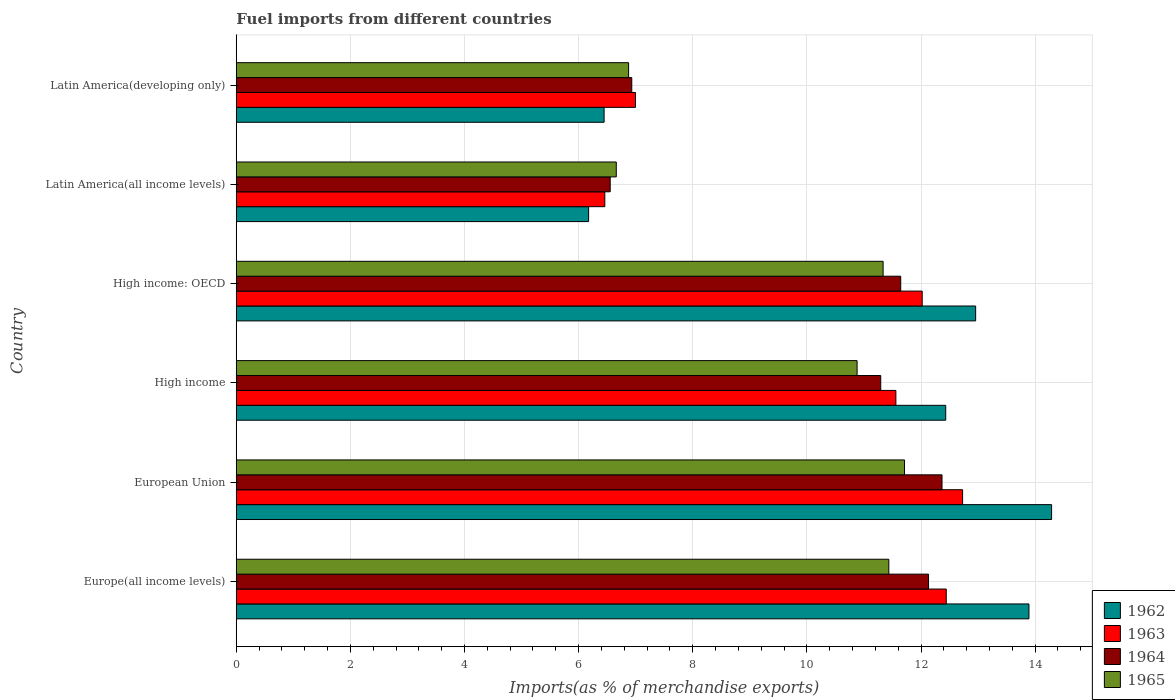How many different coloured bars are there?
Provide a short and direct response. 4. Are the number of bars per tick equal to the number of legend labels?
Your answer should be very brief. Yes. How many bars are there on the 6th tick from the bottom?
Ensure brevity in your answer.  4. What is the label of the 4th group of bars from the top?
Give a very brief answer. High income. What is the percentage of imports to different countries in 1962 in Europe(all income levels)?
Offer a terse response. 13.89. Across all countries, what is the maximum percentage of imports to different countries in 1962?
Provide a short and direct response. 14.29. Across all countries, what is the minimum percentage of imports to different countries in 1964?
Keep it short and to the point. 6.55. In which country was the percentage of imports to different countries in 1963 minimum?
Your response must be concise. Latin America(all income levels). What is the total percentage of imports to different countries in 1964 in the graph?
Ensure brevity in your answer.  60.92. What is the difference between the percentage of imports to different countries in 1964 in Europe(all income levels) and that in Latin America(developing only)?
Your answer should be compact. 5.2. What is the difference between the percentage of imports to different countries in 1965 in Latin America(all income levels) and the percentage of imports to different countries in 1963 in High income?
Give a very brief answer. -4.9. What is the average percentage of imports to different countries in 1965 per country?
Keep it short and to the point. 9.82. What is the difference between the percentage of imports to different countries in 1964 and percentage of imports to different countries in 1962 in European Union?
Offer a very short reply. -1.92. What is the ratio of the percentage of imports to different countries in 1963 in High income: OECD to that in Latin America(developing only)?
Your answer should be compact. 1.72. Is the percentage of imports to different countries in 1963 in High income: OECD less than that in Latin America(developing only)?
Provide a short and direct response. No. Is the difference between the percentage of imports to different countries in 1964 in High income: OECD and Latin America(all income levels) greater than the difference between the percentage of imports to different countries in 1962 in High income: OECD and Latin America(all income levels)?
Give a very brief answer. No. What is the difference between the highest and the second highest percentage of imports to different countries in 1965?
Give a very brief answer. 0.27. What is the difference between the highest and the lowest percentage of imports to different countries in 1964?
Make the answer very short. 5.81. In how many countries, is the percentage of imports to different countries in 1965 greater than the average percentage of imports to different countries in 1965 taken over all countries?
Your answer should be very brief. 4. Is the sum of the percentage of imports to different countries in 1965 in Europe(all income levels) and European Union greater than the maximum percentage of imports to different countries in 1962 across all countries?
Give a very brief answer. Yes. Is it the case that in every country, the sum of the percentage of imports to different countries in 1963 and percentage of imports to different countries in 1962 is greater than the sum of percentage of imports to different countries in 1964 and percentage of imports to different countries in 1965?
Your answer should be compact. No. What does the 4th bar from the bottom in Latin America(developing only) represents?
Provide a short and direct response. 1965. Is it the case that in every country, the sum of the percentage of imports to different countries in 1962 and percentage of imports to different countries in 1964 is greater than the percentage of imports to different countries in 1965?
Your answer should be very brief. Yes. How many bars are there?
Give a very brief answer. 24. Are all the bars in the graph horizontal?
Provide a short and direct response. Yes. What is the difference between two consecutive major ticks on the X-axis?
Your answer should be very brief. 2. Does the graph contain any zero values?
Offer a terse response. No. How many legend labels are there?
Your answer should be compact. 4. What is the title of the graph?
Ensure brevity in your answer.  Fuel imports from different countries. Does "1975" appear as one of the legend labels in the graph?
Your response must be concise. No. What is the label or title of the X-axis?
Offer a terse response. Imports(as % of merchandise exports). What is the label or title of the Y-axis?
Keep it short and to the point. Country. What is the Imports(as % of merchandise exports) in 1962 in Europe(all income levels)?
Your response must be concise. 13.89. What is the Imports(as % of merchandise exports) of 1963 in Europe(all income levels)?
Keep it short and to the point. 12.44. What is the Imports(as % of merchandise exports) in 1964 in Europe(all income levels)?
Make the answer very short. 12.13. What is the Imports(as % of merchandise exports) of 1965 in Europe(all income levels)?
Give a very brief answer. 11.44. What is the Imports(as % of merchandise exports) of 1962 in European Union?
Keep it short and to the point. 14.29. What is the Imports(as % of merchandise exports) in 1963 in European Union?
Give a very brief answer. 12.73. What is the Imports(as % of merchandise exports) of 1964 in European Union?
Offer a very short reply. 12.37. What is the Imports(as % of merchandise exports) in 1965 in European Union?
Offer a very short reply. 11.71. What is the Imports(as % of merchandise exports) in 1962 in High income?
Provide a short and direct response. 12.43. What is the Imports(as % of merchandise exports) of 1963 in High income?
Offer a very short reply. 11.56. What is the Imports(as % of merchandise exports) of 1964 in High income?
Offer a very short reply. 11.29. What is the Imports(as % of merchandise exports) in 1965 in High income?
Your response must be concise. 10.88. What is the Imports(as % of merchandise exports) in 1962 in High income: OECD?
Your answer should be compact. 12.96. What is the Imports(as % of merchandise exports) of 1963 in High income: OECD?
Provide a short and direct response. 12.02. What is the Imports(as % of merchandise exports) of 1964 in High income: OECD?
Provide a short and direct response. 11.64. What is the Imports(as % of merchandise exports) of 1965 in High income: OECD?
Provide a short and direct response. 11.34. What is the Imports(as % of merchandise exports) of 1962 in Latin America(all income levels)?
Keep it short and to the point. 6.17. What is the Imports(as % of merchandise exports) of 1963 in Latin America(all income levels)?
Your answer should be compact. 6.46. What is the Imports(as % of merchandise exports) of 1964 in Latin America(all income levels)?
Make the answer very short. 6.55. What is the Imports(as % of merchandise exports) in 1965 in Latin America(all income levels)?
Offer a terse response. 6.66. What is the Imports(as % of merchandise exports) of 1962 in Latin America(developing only)?
Give a very brief answer. 6.45. What is the Imports(as % of merchandise exports) in 1963 in Latin America(developing only)?
Give a very brief answer. 7. What is the Imports(as % of merchandise exports) in 1964 in Latin America(developing only)?
Provide a succinct answer. 6.93. What is the Imports(as % of merchandise exports) in 1965 in Latin America(developing only)?
Give a very brief answer. 6.88. Across all countries, what is the maximum Imports(as % of merchandise exports) of 1962?
Keep it short and to the point. 14.29. Across all countries, what is the maximum Imports(as % of merchandise exports) in 1963?
Keep it short and to the point. 12.73. Across all countries, what is the maximum Imports(as % of merchandise exports) of 1964?
Ensure brevity in your answer.  12.37. Across all countries, what is the maximum Imports(as % of merchandise exports) in 1965?
Your answer should be compact. 11.71. Across all countries, what is the minimum Imports(as % of merchandise exports) of 1962?
Provide a short and direct response. 6.17. Across all countries, what is the minimum Imports(as % of merchandise exports) of 1963?
Give a very brief answer. 6.46. Across all countries, what is the minimum Imports(as % of merchandise exports) of 1964?
Your response must be concise. 6.55. Across all countries, what is the minimum Imports(as % of merchandise exports) of 1965?
Offer a terse response. 6.66. What is the total Imports(as % of merchandise exports) in 1962 in the graph?
Provide a succinct answer. 66.19. What is the total Imports(as % of merchandise exports) of 1963 in the graph?
Make the answer very short. 62.21. What is the total Imports(as % of merchandise exports) in 1964 in the graph?
Provide a succinct answer. 60.92. What is the total Imports(as % of merchandise exports) in 1965 in the graph?
Provide a short and direct response. 58.9. What is the difference between the Imports(as % of merchandise exports) of 1962 in Europe(all income levels) and that in European Union?
Provide a short and direct response. -0.4. What is the difference between the Imports(as % of merchandise exports) of 1963 in Europe(all income levels) and that in European Union?
Your answer should be very brief. -0.29. What is the difference between the Imports(as % of merchandise exports) in 1964 in Europe(all income levels) and that in European Union?
Keep it short and to the point. -0.24. What is the difference between the Imports(as % of merchandise exports) of 1965 in Europe(all income levels) and that in European Union?
Offer a terse response. -0.27. What is the difference between the Imports(as % of merchandise exports) in 1962 in Europe(all income levels) and that in High income?
Your answer should be compact. 1.46. What is the difference between the Imports(as % of merchandise exports) in 1963 in Europe(all income levels) and that in High income?
Provide a succinct answer. 0.88. What is the difference between the Imports(as % of merchandise exports) in 1964 in Europe(all income levels) and that in High income?
Provide a short and direct response. 0.84. What is the difference between the Imports(as % of merchandise exports) of 1965 in Europe(all income levels) and that in High income?
Keep it short and to the point. 0.56. What is the difference between the Imports(as % of merchandise exports) of 1962 in Europe(all income levels) and that in High income: OECD?
Give a very brief answer. 0.93. What is the difference between the Imports(as % of merchandise exports) of 1963 in Europe(all income levels) and that in High income: OECD?
Ensure brevity in your answer.  0.42. What is the difference between the Imports(as % of merchandise exports) in 1964 in Europe(all income levels) and that in High income: OECD?
Your response must be concise. 0.49. What is the difference between the Imports(as % of merchandise exports) of 1965 in Europe(all income levels) and that in High income: OECD?
Provide a succinct answer. 0.1. What is the difference between the Imports(as % of merchandise exports) in 1962 in Europe(all income levels) and that in Latin America(all income levels)?
Give a very brief answer. 7.72. What is the difference between the Imports(as % of merchandise exports) of 1963 in Europe(all income levels) and that in Latin America(all income levels)?
Your answer should be very brief. 5.98. What is the difference between the Imports(as % of merchandise exports) in 1964 in Europe(all income levels) and that in Latin America(all income levels)?
Keep it short and to the point. 5.58. What is the difference between the Imports(as % of merchandise exports) of 1965 in Europe(all income levels) and that in Latin America(all income levels)?
Provide a short and direct response. 4.78. What is the difference between the Imports(as % of merchandise exports) of 1962 in Europe(all income levels) and that in Latin America(developing only)?
Offer a very short reply. 7.45. What is the difference between the Imports(as % of merchandise exports) of 1963 in Europe(all income levels) and that in Latin America(developing only)?
Provide a short and direct response. 5.45. What is the difference between the Imports(as % of merchandise exports) in 1964 in Europe(all income levels) and that in Latin America(developing only)?
Your response must be concise. 5.2. What is the difference between the Imports(as % of merchandise exports) in 1965 in Europe(all income levels) and that in Latin America(developing only)?
Offer a very short reply. 4.56. What is the difference between the Imports(as % of merchandise exports) in 1962 in European Union and that in High income?
Offer a terse response. 1.86. What is the difference between the Imports(as % of merchandise exports) of 1963 in European Union and that in High income?
Offer a terse response. 1.17. What is the difference between the Imports(as % of merchandise exports) of 1964 in European Union and that in High income?
Keep it short and to the point. 1.07. What is the difference between the Imports(as % of merchandise exports) of 1965 in European Union and that in High income?
Make the answer very short. 0.83. What is the difference between the Imports(as % of merchandise exports) of 1962 in European Union and that in High income: OECD?
Give a very brief answer. 1.33. What is the difference between the Imports(as % of merchandise exports) in 1963 in European Union and that in High income: OECD?
Offer a very short reply. 0.71. What is the difference between the Imports(as % of merchandise exports) in 1964 in European Union and that in High income: OECD?
Your answer should be very brief. 0.72. What is the difference between the Imports(as % of merchandise exports) of 1965 in European Union and that in High income: OECD?
Give a very brief answer. 0.38. What is the difference between the Imports(as % of merchandise exports) of 1962 in European Union and that in Latin America(all income levels)?
Keep it short and to the point. 8.11. What is the difference between the Imports(as % of merchandise exports) of 1963 in European Union and that in Latin America(all income levels)?
Keep it short and to the point. 6.27. What is the difference between the Imports(as % of merchandise exports) in 1964 in European Union and that in Latin America(all income levels)?
Keep it short and to the point. 5.82. What is the difference between the Imports(as % of merchandise exports) in 1965 in European Union and that in Latin America(all income levels)?
Your response must be concise. 5.05. What is the difference between the Imports(as % of merchandise exports) of 1962 in European Union and that in Latin America(developing only)?
Give a very brief answer. 7.84. What is the difference between the Imports(as % of merchandise exports) in 1963 in European Union and that in Latin America(developing only)?
Offer a very short reply. 5.73. What is the difference between the Imports(as % of merchandise exports) of 1964 in European Union and that in Latin America(developing only)?
Make the answer very short. 5.44. What is the difference between the Imports(as % of merchandise exports) in 1965 in European Union and that in Latin America(developing only)?
Provide a succinct answer. 4.84. What is the difference between the Imports(as % of merchandise exports) in 1962 in High income and that in High income: OECD?
Your response must be concise. -0.52. What is the difference between the Imports(as % of merchandise exports) of 1963 in High income and that in High income: OECD?
Ensure brevity in your answer.  -0.46. What is the difference between the Imports(as % of merchandise exports) of 1964 in High income and that in High income: OECD?
Make the answer very short. -0.35. What is the difference between the Imports(as % of merchandise exports) in 1965 in High income and that in High income: OECD?
Your response must be concise. -0.46. What is the difference between the Imports(as % of merchandise exports) of 1962 in High income and that in Latin America(all income levels)?
Provide a short and direct response. 6.26. What is the difference between the Imports(as % of merchandise exports) of 1963 in High income and that in Latin America(all income levels)?
Your answer should be very brief. 5.1. What is the difference between the Imports(as % of merchandise exports) of 1964 in High income and that in Latin America(all income levels)?
Your answer should be very brief. 4.74. What is the difference between the Imports(as % of merchandise exports) in 1965 in High income and that in Latin America(all income levels)?
Offer a very short reply. 4.22. What is the difference between the Imports(as % of merchandise exports) in 1962 in High income and that in Latin America(developing only)?
Your answer should be compact. 5.99. What is the difference between the Imports(as % of merchandise exports) in 1963 in High income and that in Latin America(developing only)?
Your response must be concise. 4.56. What is the difference between the Imports(as % of merchandise exports) of 1964 in High income and that in Latin America(developing only)?
Offer a terse response. 4.36. What is the difference between the Imports(as % of merchandise exports) of 1965 in High income and that in Latin America(developing only)?
Keep it short and to the point. 4. What is the difference between the Imports(as % of merchandise exports) of 1962 in High income: OECD and that in Latin America(all income levels)?
Ensure brevity in your answer.  6.78. What is the difference between the Imports(as % of merchandise exports) of 1963 in High income: OECD and that in Latin America(all income levels)?
Keep it short and to the point. 5.56. What is the difference between the Imports(as % of merchandise exports) of 1964 in High income: OECD and that in Latin America(all income levels)?
Offer a terse response. 5.09. What is the difference between the Imports(as % of merchandise exports) in 1965 in High income: OECD and that in Latin America(all income levels)?
Keep it short and to the point. 4.68. What is the difference between the Imports(as % of merchandise exports) of 1962 in High income: OECD and that in Latin America(developing only)?
Make the answer very short. 6.51. What is the difference between the Imports(as % of merchandise exports) in 1963 in High income: OECD and that in Latin America(developing only)?
Offer a terse response. 5.02. What is the difference between the Imports(as % of merchandise exports) of 1964 in High income: OECD and that in Latin America(developing only)?
Your answer should be compact. 4.71. What is the difference between the Imports(as % of merchandise exports) of 1965 in High income: OECD and that in Latin America(developing only)?
Your answer should be very brief. 4.46. What is the difference between the Imports(as % of merchandise exports) in 1962 in Latin America(all income levels) and that in Latin America(developing only)?
Your answer should be very brief. -0.27. What is the difference between the Imports(as % of merchandise exports) of 1963 in Latin America(all income levels) and that in Latin America(developing only)?
Your response must be concise. -0.54. What is the difference between the Imports(as % of merchandise exports) of 1964 in Latin America(all income levels) and that in Latin America(developing only)?
Make the answer very short. -0.38. What is the difference between the Imports(as % of merchandise exports) in 1965 in Latin America(all income levels) and that in Latin America(developing only)?
Your answer should be very brief. -0.22. What is the difference between the Imports(as % of merchandise exports) in 1962 in Europe(all income levels) and the Imports(as % of merchandise exports) in 1963 in European Union?
Your answer should be very brief. 1.16. What is the difference between the Imports(as % of merchandise exports) of 1962 in Europe(all income levels) and the Imports(as % of merchandise exports) of 1964 in European Union?
Offer a very short reply. 1.52. What is the difference between the Imports(as % of merchandise exports) in 1962 in Europe(all income levels) and the Imports(as % of merchandise exports) in 1965 in European Union?
Give a very brief answer. 2.18. What is the difference between the Imports(as % of merchandise exports) in 1963 in Europe(all income levels) and the Imports(as % of merchandise exports) in 1964 in European Union?
Give a very brief answer. 0.07. What is the difference between the Imports(as % of merchandise exports) of 1963 in Europe(all income levels) and the Imports(as % of merchandise exports) of 1965 in European Union?
Your response must be concise. 0.73. What is the difference between the Imports(as % of merchandise exports) in 1964 in Europe(all income levels) and the Imports(as % of merchandise exports) in 1965 in European Union?
Offer a terse response. 0.42. What is the difference between the Imports(as % of merchandise exports) in 1962 in Europe(all income levels) and the Imports(as % of merchandise exports) in 1963 in High income?
Ensure brevity in your answer.  2.33. What is the difference between the Imports(as % of merchandise exports) in 1962 in Europe(all income levels) and the Imports(as % of merchandise exports) in 1964 in High income?
Make the answer very short. 2.6. What is the difference between the Imports(as % of merchandise exports) of 1962 in Europe(all income levels) and the Imports(as % of merchandise exports) of 1965 in High income?
Keep it short and to the point. 3.01. What is the difference between the Imports(as % of merchandise exports) of 1963 in Europe(all income levels) and the Imports(as % of merchandise exports) of 1964 in High income?
Offer a terse response. 1.15. What is the difference between the Imports(as % of merchandise exports) in 1963 in Europe(all income levels) and the Imports(as % of merchandise exports) in 1965 in High income?
Your answer should be very brief. 1.56. What is the difference between the Imports(as % of merchandise exports) of 1964 in Europe(all income levels) and the Imports(as % of merchandise exports) of 1965 in High income?
Offer a very short reply. 1.25. What is the difference between the Imports(as % of merchandise exports) in 1962 in Europe(all income levels) and the Imports(as % of merchandise exports) in 1963 in High income: OECD?
Give a very brief answer. 1.87. What is the difference between the Imports(as % of merchandise exports) in 1962 in Europe(all income levels) and the Imports(as % of merchandise exports) in 1964 in High income: OECD?
Your answer should be very brief. 2.25. What is the difference between the Imports(as % of merchandise exports) of 1962 in Europe(all income levels) and the Imports(as % of merchandise exports) of 1965 in High income: OECD?
Provide a short and direct response. 2.56. What is the difference between the Imports(as % of merchandise exports) in 1963 in Europe(all income levels) and the Imports(as % of merchandise exports) in 1964 in High income: OECD?
Your answer should be compact. 0.8. What is the difference between the Imports(as % of merchandise exports) in 1963 in Europe(all income levels) and the Imports(as % of merchandise exports) in 1965 in High income: OECD?
Make the answer very short. 1.11. What is the difference between the Imports(as % of merchandise exports) of 1964 in Europe(all income levels) and the Imports(as % of merchandise exports) of 1965 in High income: OECD?
Make the answer very short. 0.8. What is the difference between the Imports(as % of merchandise exports) in 1962 in Europe(all income levels) and the Imports(as % of merchandise exports) in 1963 in Latin America(all income levels)?
Offer a very short reply. 7.43. What is the difference between the Imports(as % of merchandise exports) in 1962 in Europe(all income levels) and the Imports(as % of merchandise exports) in 1964 in Latin America(all income levels)?
Offer a terse response. 7.34. What is the difference between the Imports(as % of merchandise exports) of 1962 in Europe(all income levels) and the Imports(as % of merchandise exports) of 1965 in Latin America(all income levels)?
Offer a very short reply. 7.23. What is the difference between the Imports(as % of merchandise exports) in 1963 in Europe(all income levels) and the Imports(as % of merchandise exports) in 1964 in Latin America(all income levels)?
Provide a short and direct response. 5.89. What is the difference between the Imports(as % of merchandise exports) in 1963 in Europe(all income levels) and the Imports(as % of merchandise exports) in 1965 in Latin America(all income levels)?
Offer a very short reply. 5.78. What is the difference between the Imports(as % of merchandise exports) of 1964 in Europe(all income levels) and the Imports(as % of merchandise exports) of 1965 in Latin America(all income levels)?
Your answer should be very brief. 5.47. What is the difference between the Imports(as % of merchandise exports) in 1962 in Europe(all income levels) and the Imports(as % of merchandise exports) in 1963 in Latin America(developing only)?
Ensure brevity in your answer.  6.9. What is the difference between the Imports(as % of merchandise exports) in 1962 in Europe(all income levels) and the Imports(as % of merchandise exports) in 1964 in Latin America(developing only)?
Your answer should be very brief. 6.96. What is the difference between the Imports(as % of merchandise exports) in 1962 in Europe(all income levels) and the Imports(as % of merchandise exports) in 1965 in Latin America(developing only)?
Your answer should be compact. 7.02. What is the difference between the Imports(as % of merchandise exports) in 1963 in Europe(all income levels) and the Imports(as % of merchandise exports) in 1964 in Latin America(developing only)?
Provide a short and direct response. 5.51. What is the difference between the Imports(as % of merchandise exports) in 1963 in Europe(all income levels) and the Imports(as % of merchandise exports) in 1965 in Latin America(developing only)?
Your answer should be compact. 5.57. What is the difference between the Imports(as % of merchandise exports) of 1964 in Europe(all income levels) and the Imports(as % of merchandise exports) of 1965 in Latin America(developing only)?
Give a very brief answer. 5.26. What is the difference between the Imports(as % of merchandise exports) in 1962 in European Union and the Imports(as % of merchandise exports) in 1963 in High income?
Offer a terse response. 2.73. What is the difference between the Imports(as % of merchandise exports) of 1962 in European Union and the Imports(as % of merchandise exports) of 1964 in High income?
Offer a very short reply. 2.99. What is the difference between the Imports(as % of merchandise exports) in 1962 in European Union and the Imports(as % of merchandise exports) in 1965 in High income?
Provide a succinct answer. 3.41. What is the difference between the Imports(as % of merchandise exports) of 1963 in European Union and the Imports(as % of merchandise exports) of 1964 in High income?
Your answer should be very brief. 1.43. What is the difference between the Imports(as % of merchandise exports) of 1963 in European Union and the Imports(as % of merchandise exports) of 1965 in High income?
Your answer should be compact. 1.85. What is the difference between the Imports(as % of merchandise exports) in 1964 in European Union and the Imports(as % of merchandise exports) in 1965 in High income?
Provide a short and direct response. 1.49. What is the difference between the Imports(as % of merchandise exports) in 1962 in European Union and the Imports(as % of merchandise exports) in 1963 in High income: OECD?
Ensure brevity in your answer.  2.27. What is the difference between the Imports(as % of merchandise exports) in 1962 in European Union and the Imports(as % of merchandise exports) in 1964 in High income: OECD?
Your response must be concise. 2.64. What is the difference between the Imports(as % of merchandise exports) in 1962 in European Union and the Imports(as % of merchandise exports) in 1965 in High income: OECD?
Offer a terse response. 2.95. What is the difference between the Imports(as % of merchandise exports) in 1963 in European Union and the Imports(as % of merchandise exports) in 1964 in High income: OECD?
Your response must be concise. 1.08. What is the difference between the Imports(as % of merchandise exports) in 1963 in European Union and the Imports(as % of merchandise exports) in 1965 in High income: OECD?
Give a very brief answer. 1.39. What is the difference between the Imports(as % of merchandise exports) in 1964 in European Union and the Imports(as % of merchandise exports) in 1965 in High income: OECD?
Offer a terse response. 1.03. What is the difference between the Imports(as % of merchandise exports) in 1962 in European Union and the Imports(as % of merchandise exports) in 1963 in Latin America(all income levels)?
Provide a succinct answer. 7.83. What is the difference between the Imports(as % of merchandise exports) of 1962 in European Union and the Imports(as % of merchandise exports) of 1964 in Latin America(all income levels)?
Provide a short and direct response. 7.74. What is the difference between the Imports(as % of merchandise exports) in 1962 in European Union and the Imports(as % of merchandise exports) in 1965 in Latin America(all income levels)?
Your response must be concise. 7.63. What is the difference between the Imports(as % of merchandise exports) in 1963 in European Union and the Imports(as % of merchandise exports) in 1964 in Latin America(all income levels)?
Make the answer very short. 6.18. What is the difference between the Imports(as % of merchandise exports) of 1963 in European Union and the Imports(as % of merchandise exports) of 1965 in Latin America(all income levels)?
Your answer should be very brief. 6.07. What is the difference between the Imports(as % of merchandise exports) of 1964 in European Union and the Imports(as % of merchandise exports) of 1965 in Latin America(all income levels)?
Provide a succinct answer. 5.71. What is the difference between the Imports(as % of merchandise exports) in 1962 in European Union and the Imports(as % of merchandise exports) in 1963 in Latin America(developing only)?
Give a very brief answer. 7.29. What is the difference between the Imports(as % of merchandise exports) of 1962 in European Union and the Imports(as % of merchandise exports) of 1964 in Latin America(developing only)?
Your response must be concise. 7.36. What is the difference between the Imports(as % of merchandise exports) of 1962 in European Union and the Imports(as % of merchandise exports) of 1965 in Latin America(developing only)?
Keep it short and to the point. 7.41. What is the difference between the Imports(as % of merchandise exports) of 1963 in European Union and the Imports(as % of merchandise exports) of 1964 in Latin America(developing only)?
Your answer should be very brief. 5.8. What is the difference between the Imports(as % of merchandise exports) of 1963 in European Union and the Imports(as % of merchandise exports) of 1965 in Latin America(developing only)?
Provide a short and direct response. 5.85. What is the difference between the Imports(as % of merchandise exports) of 1964 in European Union and the Imports(as % of merchandise exports) of 1965 in Latin America(developing only)?
Offer a terse response. 5.49. What is the difference between the Imports(as % of merchandise exports) in 1962 in High income and the Imports(as % of merchandise exports) in 1963 in High income: OECD?
Your answer should be very brief. 0.41. What is the difference between the Imports(as % of merchandise exports) of 1962 in High income and the Imports(as % of merchandise exports) of 1964 in High income: OECD?
Keep it short and to the point. 0.79. What is the difference between the Imports(as % of merchandise exports) in 1962 in High income and the Imports(as % of merchandise exports) in 1965 in High income: OECD?
Offer a very short reply. 1.1. What is the difference between the Imports(as % of merchandise exports) in 1963 in High income and the Imports(as % of merchandise exports) in 1964 in High income: OECD?
Ensure brevity in your answer.  -0.09. What is the difference between the Imports(as % of merchandise exports) in 1963 in High income and the Imports(as % of merchandise exports) in 1965 in High income: OECD?
Your answer should be very brief. 0.22. What is the difference between the Imports(as % of merchandise exports) in 1964 in High income and the Imports(as % of merchandise exports) in 1965 in High income: OECD?
Ensure brevity in your answer.  -0.04. What is the difference between the Imports(as % of merchandise exports) in 1962 in High income and the Imports(as % of merchandise exports) in 1963 in Latin America(all income levels)?
Your response must be concise. 5.97. What is the difference between the Imports(as % of merchandise exports) of 1962 in High income and the Imports(as % of merchandise exports) of 1964 in Latin America(all income levels)?
Provide a succinct answer. 5.88. What is the difference between the Imports(as % of merchandise exports) of 1962 in High income and the Imports(as % of merchandise exports) of 1965 in Latin America(all income levels)?
Provide a succinct answer. 5.77. What is the difference between the Imports(as % of merchandise exports) of 1963 in High income and the Imports(as % of merchandise exports) of 1964 in Latin America(all income levels)?
Keep it short and to the point. 5.01. What is the difference between the Imports(as % of merchandise exports) of 1963 in High income and the Imports(as % of merchandise exports) of 1965 in Latin America(all income levels)?
Provide a succinct answer. 4.9. What is the difference between the Imports(as % of merchandise exports) in 1964 in High income and the Imports(as % of merchandise exports) in 1965 in Latin America(all income levels)?
Your response must be concise. 4.63. What is the difference between the Imports(as % of merchandise exports) in 1962 in High income and the Imports(as % of merchandise exports) in 1963 in Latin America(developing only)?
Give a very brief answer. 5.44. What is the difference between the Imports(as % of merchandise exports) in 1962 in High income and the Imports(as % of merchandise exports) in 1964 in Latin America(developing only)?
Offer a terse response. 5.5. What is the difference between the Imports(as % of merchandise exports) in 1962 in High income and the Imports(as % of merchandise exports) in 1965 in Latin America(developing only)?
Keep it short and to the point. 5.56. What is the difference between the Imports(as % of merchandise exports) of 1963 in High income and the Imports(as % of merchandise exports) of 1964 in Latin America(developing only)?
Your answer should be very brief. 4.63. What is the difference between the Imports(as % of merchandise exports) in 1963 in High income and the Imports(as % of merchandise exports) in 1965 in Latin America(developing only)?
Ensure brevity in your answer.  4.68. What is the difference between the Imports(as % of merchandise exports) of 1964 in High income and the Imports(as % of merchandise exports) of 1965 in Latin America(developing only)?
Provide a short and direct response. 4.42. What is the difference between the Imports(as % of merchandise exports) in 1962 in High income: OECD and the Imports(as % of merchandise exports) in 1963 in Latin America(all income levels)?
Give a very brief answer. 6.5. What is the difference between the Imports(as % of merchandise exports) of 1962 in High income: OECD and the Imports(as % of merchandise exports) of 1964 in Latin America(all income levels)?
Give a very brief answer. 6.4. What is the difference between the Imports(as % of merchandise exports) in 1962 in High income: OECD and the Imports(as % of merchandise exports) in 1965 in Latin America(all income levels)?
Give a very brief answer. 6.3. What is the difference between the Imports(as % of merchandise exports) of 1963 in High income: OECD and the Imports(as % of merchandise exports) of 1964 in Latin America(all income levels)?
Give a very brief answer. 5.47. What is the difference between the Imports(as % of merchandise exports) in 1963 in High income: OECD and the Imports(as % of merchandise exports) in 1965 in Latin America(all income levels)?
Keep it short and to the point. 5.36. What is the difference between the Imports(as % of merchandise exports) of 1964 in High income: OECD and the Imports(as % of merchandise exports) of 1965 in Latin America(all income levels)?
Provide a succinct answer. 4.98. What is the difference between the Imports(as % of merchandise exports) of 1962 in High income: OECD and the Imports(as % of merchandise exports) of 1963 in Latin America(developing only)?
Your answer should be compact. 5.96. What is the difference between the Imports(as % of merchandise exports) in 1962 in High income: OECD and the Imports(as % of merchandise exports) in 1964 in Latin America(developing only)?
Your response must be concise. 6.03. What is the difference between the Imports(as % of merchandise exports) in 1962 in High income: OECD and the Imports(as % of merchandise exports) in 1965 in Latin America(developing only)?
Your response must be concise. 6.08. What is the difference between the Imports(as % of merchandise exports) of 1963 in High income: OECD and the Imports(as % of merchandise exports) of 1964 in Latin America(developing only)?
Your answer should be very brief. 5.09. What is the difference between the Imports(as % of merchandise exports) of 1963 in High income: OECD and the Imports(as % of merchandise exports) of 1965 in Latin America(developing only)?
Keep it short and to the point. 5.15. What is the difference between the Imports(as % of merchandise exports) in 1964 in High income: OECD and the Imports(as % of merchandise exports) in 1965 in Latin America(developing only)?
Provide a succinct answer. 4.77. What is the difference between the Imports(as % of merchandise exports) of 1962 in Latin America(all income levels) and the Imports(as % of merchandise exports) of 1963 in Latin America(developing only)?
Make the answer very short. -0.82. What is the difference between the Imports(as % of merchandise exports) of 1962 in Latin America(all income levels) and the Imports(as % of merchandise exports) of 1964 in Latin America(developing only)?
Give a very brief answer. -0.76. What is the difference between the Imports(as % of merchandise exports) of 1962 in Latin America(all income levels) and the Imports(as % of merchandise exports) of 1965 in Latin America(developing only)?
Your answer should be very brief. -0.7. What is the difference between the Imports(as % of merchandise exports) of 1963 in Latin America(all income levels) and the Imports(as % of merchandise exports) of 1964 in Latin America(developing only)?
Your response must be concise. -0.47. What is the difference between the Imports(as % of merchandise exports) in 1963 in Latin America(all income levels) and the Imports(as % of merchandise exports) in 1965 in Latin America(developing only)?
Offer a terse response. -0.42. What is the difference between the Imports(as % of merchandise exports) in 1964 in Latin America(all income levels) and the Imports(as % of merchandise exports) in 1965 in Latin America(developing only)?
Your answer should be very brief. -0.32. What is the average Imports(as % of merchandise exports) in 1962 per country?
Your response must be concise. 11.03. What is the average Imports(as % of merchandise exports) of 1963 per country?
Your answer should be very brief. 10.37. What is the average Imports(as % of merchandise exports) in 1964 per country?
Provide a short and direct response. 10.15. What is the average Imports(as % of merchandise exports) of 1965 per country?
Ensure brevity in your answer.  9.82. What is the difference between the Imports(as % of merchandise exports) of 1962 and Imports(as % of merchandise exports) of 1963 in Europe(all income levels)?
Ensure brevity in your answer.  1.45. What is the difference between the Imports(as % of merchandise exports) of 1962 and Imports(as % of merchandise exports) of 1964 in Europe(all income levels)?
Give a very brief answer. 1.76. What is the difference between the Imports(as % of merchandise exports) in 1962 and Imports(as % of merchandise exports) in 1965 in Europe(all income levels)?
Your response must be concise. 2.46. What is the difference between the Imports(as % of merchandise exports) of 1963 and Imports(as % of merchandise exports) of 1964 in Europe(all income levels)?
Give a very brief answer. 0.31. What is the difference between the Imports(as % of merchandise exports) of 1963 and Imports(as % of merchandise exports) of 1965 in Europe(all income levels)?
Make the answer very short. 1.01. What is the difference between the Imports(as % of merchandise exports) of 1964 and Imports(as % of merchandise exports) of 1965 in Europe(all income levels)?
Provide a short and direct response. 0.7. What is the difference between the Imports(as % of merchandise exports) in 1962 and Imports(as % of merchandise exports) in 1963 in European Union?
Ensure brevity in your answer.  1.56. What is the difference between the Imports(as % of merchandise exports) of 1962 and Imports(as % of merchandise exports) of 1964 in European Union?
Offer a very short reply. 1.92. What is the difference between the Imports(as % of merchandise exports) of 1962 and Imports(as % of merchandise exports) of 1965 in European Union?
Your answer should be very brief. 2.58. What is the difference between the Imports(as % of merchandise exports) of 1963 and Imports(as % of merchandise exports) of 1964 in European Union?
Make the answer very short. 0.36. What is the difference between the Imports(as % of merchandise exports) in 1963 and Imports(as % of merchandise exports) in 1965 in European Union?
Provide a short and direct response. 1.02. What is the difference between the Imports(as % of merchandise exports) of 1964 and Imports(as % of merchandise exports) of 1965 in European Union?
Offer a terse response. 0.66. What is the difference between the Imports(as % of merchandise exports) in 1962 and Imports(as % of merchandise exports) in 1963 in High income?
Offer a terse response. 0.87. What is the difference between the Imports(as % of merchandise exports) in 1962 and Imports(as % of merchandise exports) in 1964 in High income?
Provide a short and direct response. 1.14. What is the difference between the Imports(as % of merchandise exports) of 1962 and Imports(as % of merchandise exports) of 1965 in High income?
Keep it short and to the point. 1.55. What is the difference between the Imports(as % of merchandise exports) of 1963 and Imports(as % of merchandise exports) of 1964 in High income?
Provide a succinct answer. 0.27. What is the difference between the Imports(as % of merchandise exports) in 1963 and Imports(as % of merchandise exports) in 1965 in High income?
Give a very brief answer. 0.68. What is the difference between the Imports(as % of merchandise exports) of 1964 and Imports(as % of merchandise exports) of 1965 in High income?
Keep it short and to the point. 0.41. What is the difference between the Imports(as % of merchandise exports) in 1962 and Imports(as % of merchandise exports) in 1963 in High income: OECD?
Your answer should be very brief. 0.94. What is the difference between the Imports(as % of merchandise exports) in 1962 and Imports(as % of merchandise exports) in 1964 in High income: OECD?
Your answer should be compact. 1.31. What is the difference between the Imports(as % of merchandise exports) in 1962 and Imports(as % of merchandise exports) in 1965 in High income: OECD?
Offer a terse response. 1.62. What is the difference between the Imports(as % of merchandise exports) of 1963 and Imports(as % of merchandise exports) of 1964 in High income: OECD?
Ensure brevity in your answer.  0.38. What is the difference between the Imports(as % of merchandise exports) in 1963 and Imports(as % of merchandise exports) in 1965 in High income: OECD?
Your answer should be compact. 0.69. What is the difference between the Imports(as % of merchandise exports) in 1964 and Imports(as % of merchandise exports) in 1965 in High income: OECD?
Make the answer very short. 0.31. What is the difference between the Imports(as % of merchandise exports) in 1962 and Imports(as % of merchandise exports) in 1963 in Latin America(all income levels)?
Your response must be concise. -0.28. What is the difference between the Imports(as % of merchandise exports) of 1962 and Imports(as % of merchandise exports) of 1964 in Latin America(all income levels)?
Offer a very short reply. -0.38. What is the difference between the Imports(as % of merchandise exports) of 1962 and Imports(as % of merchandise exports) of 1965 in Latin America(all income levels)?
Your answer should be compact. -0.48. What is the difference between the Imports(as % of merchandise exports) in 1963 and Imports(as % of merchandise exports) in 1964 in Latin America(all income levels)?
Provide a succinct answer. -0.09. What is the difference between the Imports(as % of merchandise exports) of 1963 and Imports(as % of merchandise exports) of 1965 in Latin America(all income levels)?
Offer a terse response. -0.2. What is the difference between the Imports(as % of merchandise exports) in 1964 and Imports(as % of merchandise exports) in 1965 in Latin America(all income levels)?
Make the answer very short. -0.11. What is the difference between the Imports(as % of merchandise exports) in 1962 and Imports(as % of merchandise exports) in 1963 in Latin America(developing only)?
Your answer should be compact. -0.55. What is the difference between the Imports(as % of merchandise exports) in 1962 and Imports(as % of merchandise exports) in 1964 in Latin America(developing only)?
Your response must be concise. -0.48. What is the difference between the Imports(as % of merchandise exports) of 1962 and Imports(as % of merchandise exports) of 1965 in Latin America(developing only)?
Your answer should be compact. -0.43. What is the difference between the Imports(as % of merchandise exports) in 1963 and Imports(as % of merchandise exports) in 1964 in Latin America(developing only)?
Ensure brevity in your answer.  0.07. What is the difference between the Imports(as % of merchandise exports) in 1963 and Imports(as % of merchandise exports) in 1965 in Latin America(developing only)?
Your answer should be very brief. 0.12. What is the difference between the Imports(as % of merchandise exports) of 1964 and Imports(as % of merchandise exports) of 1965 in Latin America(developing only)?
Keep it short and to the point. 0.06. What is the ratio of the Imports(as % of merchandise exports) of 1962 in Europe(all income levels) to that in European Union?
Provide a short and direct response. 0.97. What is the ratio of the Imports(as % of merchandise exports) in 1963 in Europe(all income levels) to that in European Union?
Your response must be concise. 0.98. What is the ratio of the Imports(as % of merchandise exports) of 1964 in Europe(all income levels) to that in European Union?
Give a very brief answer. 0.98. What is the ratio of the Imports(as % of merchandise exports) in 1965 in Europe(all income levels) to that in European Union?
Ensure brevity in your answer.  0.98. What is the ratio of the Imports(as % of merchandise exports) in 1962 in Europe(all income levels) to that in High income?
Your answer should be compact. 1.12. What is the ratio of the Imports(as % of merchandise exports) in 1963 in Europe(all income levels) to that in High income?
Keep it short and to the point. 1.08. What is the ratio of the Imports(as % of merchandise exports) in 1964 in Europe(all income levels) to that in High income?
Provide a short and direct response. 1.07. What is the ratio of the Imports(as % of merchandise exports) of 1965 in Europe(all income levels) to that in High income?
Your response must be concise. 1.05. What is the ratio of the Imports(as % of merchandise exports) of 1962 in Europe(all income levels) to that in High income: OECD?
Your answer should be very brief. 1.07. What is the ratio of the Imports(as % of merchandise exports) in 1963 in Europe(all income levels) to that in High income: OECD?
Make the answer very short. 1.04. What is the ratio of the Imports(as % of merchandise exports) of 1964 in Europe(all income levels) to that in High income: OECD?
Make the answer very short. 1.04. What is the ratio of the Imports(as % of merchandise exports) of 1965 in Europe(all income levels) to that in High income: OECD?
Keep it short and to the point. 1.01. What is the ratio of the Imports(as % of merchandise exports) in 1962 in Europe(all income levels) to that in Latin America(all income levels)?
Provide a succinct answer. 2.25. What is the ratio of the Imports(as % of merchandise exports) in 1963 in Europe(all income levels) to that in Latin America(all income levels)?
Your answer should be compact. 1.93. What is the ratio of the Imports(as % of merchandise exports) of 1964 in Europe(all income levels) to that in Latin America(all income levels)?
Make the answer very short. 1.85. What is the ratio of the Imports(as % of merchandise exports) in 1965 in Europe(all income levels) to that in Latin America(all income levels)?
Provide a succinct answer. 1.72. What is the ratio of the Imports(as % of merchandise exports) in 1962 in Europe(all income levels) to that in Latin America(developing only)?
Your response must be concise. 2.15. What is the ratio of the Imports(as % of merchandise exports) in 1963 in Europe(all income levels) to that in Latin America(developing only)?
Ensure brevity in your answer.  1.78. What is the ratio of the Imports(as % of merchandise exports) in 1964 in Europe(all income levels) to that in Latin America(developing only)?
Give a very brief answer. 1.75. What is the ratio of the Imports(as % of merchandise exports) of 1965 in Europe(all income levels) to that in Latin America(developing only)?
Give a very brief answer. 1.66. What is the ratio of the Imports(as % of merchandise exports) of 1962 in European Union to that in High income?
Provide a short and direct response. 1.15. What is the ratio of the Imports(as % of merchandise exports) of 1963 in European Union to that in High income?
Your answer should be compact. 1.1. What is the ratio of the Imports(as % of merchandise exports) of 1964 in European Union to that in High income?
Offer a terse response. 1.1. What is the ratio of the Imports(as % of merchandise exports) of 1965 in European Union to that in High income?
Provide a short and direct response. 1.08. What is the ratio of the Imports(as % of merchandise exports) of 1962 in European Union to that in High income: OECD?
Provide a succinct answer. 1.1. What is the ratio of the Imports(as % of merchandise exports) of 1963 in European Union to that in High income: OECD?
Keep it short and to the point. 1.06. What is the ratio of the Imports(as % of merchandise exports) in 1964 in European Union to that in High income: OECD?
Offer a very short reply. 1.06. What is the ratio of the Imports(as % of merchandise exports) in 1965 in European Union to that in High income: OECD?
Your answer should be compact. 1.03. What is the ratio of the Imports(as % of merchandise exports) in 1962 in European Union to that in Latin America(all income levels)?
Your response must be concise. 2.31. What is the ratio of the Imports(as % of merchandise exports) of 1963 in European Union to that in Latin America(all income levels)?
Give a very brief answer. 1.97. What is the ratio of the Imports(as % of merchandise exports) of 1964 in European Union to that in Latin America(all income levels)?
Make the answer very short. 1.89. What is the ratio of the Imports(as % of merchandise exports) of 1965 in European Union to that in Latin America(all income levels)?
Give a very brief answer. 1.76. What is the ratio of the Imports(as % of merchandise exports) in 1962 in European Union to that in Latin America(developing only)?
Provide a succinct answer. 2.22. What is the ratio of the Imports(as % of merchandise exports) of 1963 in European Union to that in Latin America(developing only)?
Your answer should be compact. 1.82. What is the ratio of the Imports(as % of merchandise exports) of 1964 in European Union to that in Latin America(developing only)?
Ensure brevity in your answer.  1.78. What is the ratio of the Imports(as % of merchandise exports) of 1965 in European Union to that in Latin America(developing only)?
Provide a succinct answer. 1.7. What is the ratio of the Imports(as % of merchandise exports) of 1962 in High income to that in High income: OECD?
Your answer should be compact. 0.96. What is the ratio of the Imports(as % of merchandise exports) of 1963 in High income to that in High income: OECD?
Your answer should be very brief. 0.96. What is the ratio of the Imports(as % of merchandise exports) of 1964 in High income to that in High income: OECD?
Offer a terse response. 0.97. What is the ratio of the Imports(as % of merchandise exports) in 1965 in High income to that in High income: OECD?
Provide a succinct answer. 0.96. What is the ratio of the Imports(as % of merchandise exports) of 1962 in High income to that in Latin America(all income levels)?
Your answer should be very brief. 2.01. What is the ratio of the Imports(as % of merchandise exports) of 1963 in High income to that in Latin America(all income levels)?
Provide a short and direct response. 1.79. What is the ratio of the Imports(as % of merchandise exports) in 1964 in High income to that in Latin America(all income levels)?
Offer a very short reply. 1.72. What is the ratio of the Imports(as % of merchandise exports) in 1965 in High income to that in Latin America(all income levels)?
Provide a succinct answer. 1.63. What is the ratio of the Imports(as % of merchandise exports) of 1962 in High income to that in Latin America(developing only)?
Ensure brevity in your answer.  1.93. What is the ratio of the Imports(as % of merchandise exports) of 1963 in High income to that in Latin America(developing only)?
Ensure brevity in your answer.  1.65. What is the ratio of the Imports(as % of merchandise exports) in 1964 in High income to that in Latin America(developing only)?
Make the answer very short. 1.63. What is the ratio of the Imports(as % of merchandise exports) in 1965 in High income to that in Latin America(developing only)?
Offer a very short reply. 1.58. What is the ratio of the Imports(as % of merchandise exports) in 1962 in High income: OECD to that in Latin America(all income levels)?
Give a very brief answer. 2.1. What is the ratio of the Imports(as % of merchandise exports) of 1963 in High income: OECD to that in Latin America(all income levels)?
Offer a very short reply. 1.86. What is the ratio of the Imports(as % of merchandise exports) of 1964 in High income: OECD to that in Latin America(all income levels)?
Offer a very short reply. 1.78. What is the ratio of the Imports(as % of merchandise exports) of 1965 in High income: OECD to that in Latin America(all income levels)?
Keep it short and to the point. 1.7. What is the ratio of the Imports(as % of merchandise exports) in 1962 in High income: OECD to that in Latin America(developing only)?
Offer a very short reply. 2.01. What is the ratio of the Imports(as % of merchandise exports) of 1963 in High income: OECD to that in Latin America(developing only)?
Keep it short and to the point. 1.72. What is the ratio of the Imports(as % of merchandise exports) in 1964 in High income: OECD to that in Latin America(developing only)?
Your answer should be very brief. 1.68. What is the ratio of the Imports(as % of merchandise exports) in 1965 in High income: OECD to that in Latin America(developing only)?
Ensure brevity in your answer.  1.65. What is the ratio of the Imports(as % of merchandise exports) of 1962 in Latin America(all income levels) to that in Latin America(developing only)?
Give a very brief answer. 0.96. What is the ratio of the Imports(as % of merchandise exports) in 1963 in Latin America(all income levels) to that in Latin America(developing only)?
Provide a succinct answer. 0.92. What is the ratio of the Imports(as % of merchandise exports) in 1964 in Latin America(all income levels) to that in Latin America(developing only)?
Provide a succinct answer. 0.95. What is the ratio of the Imports(as % of merchandise exports) in 1965 in Latin America(all income levels) to that in Latin America(developing only)?
Your response must be concise. 0.97. What is the difference between the highest and the second highest Imports(as % of merchandise exports) of 1962?
Offer a terse response. 0.4. What is the difference between the highest and the second highest Imports(as % of merchandise exports) of 1963?
Your response must be concise. 0.29. What is the difference between the highest and the second highest Imports(as % of merchandise exports) of 1964?
Offer a very short reply. 0.24. What is the difference between the highest and the second highest Imports(as % of merchandise exports) of 1965?
Give a very brief answer. 0.27. What is the difference between the highest and the lowest Imports(as % of merchandise exports) of 1962?
Your answer should be compact. 8.11. What is the difference between the highest and the lowest Imports(as % of merchandise exports) of 1963?
Offer a terse response. 6.27. What is the difference between the highest and the lowest Imports(as % of merchandise exports) of 1964?
Keep it short and to the point. 5.82. What is the difference between the highest and the lowest Imports(as % of merchandise exports) in 1965?
Keep it short and to the point. 5.05. 